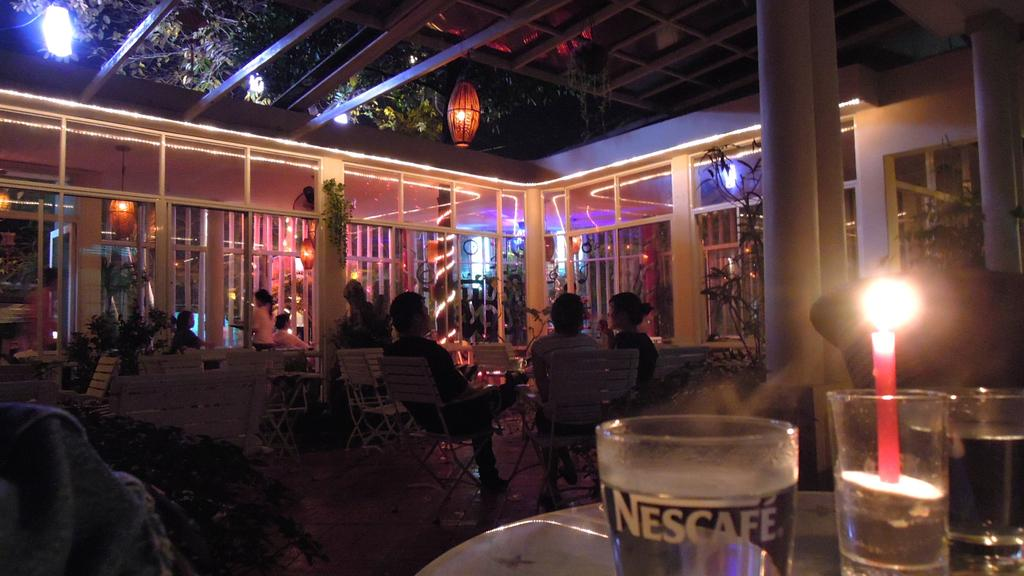<image>
Render a clear and concise summary of the photo. a restaurant with a water glass from nescafe 